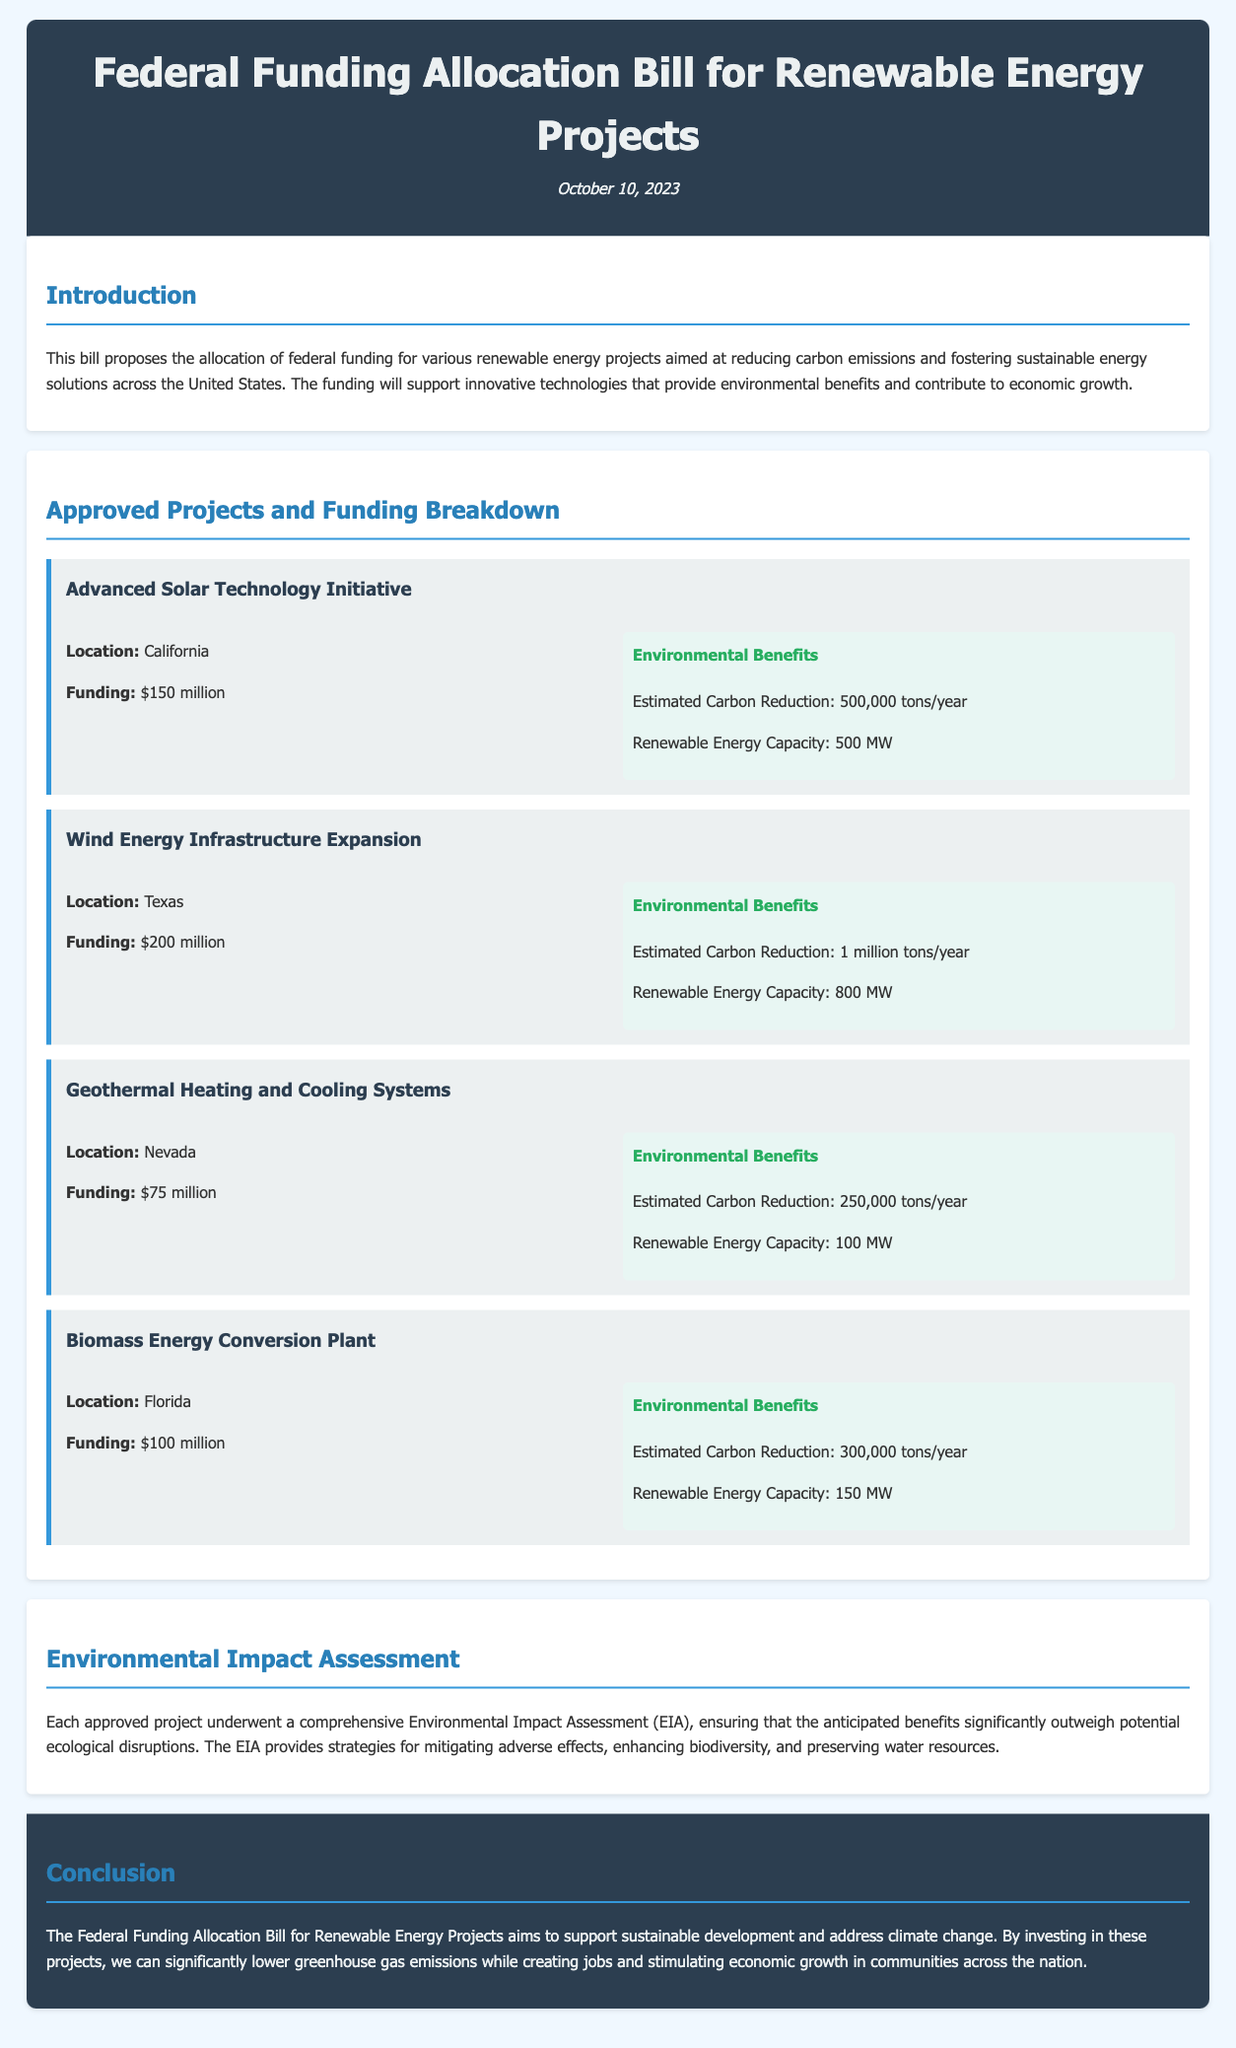what is the title of the bill? The title of the bill is stated at the top of the document.
Answer: Federal Funding Allocation Bill for Renewable Energy Projects when was the bill published? The publication date is mentioned beneath the title in the document.
Answer: October 10, 2023 how much funding is allocated to the Advanced Solar Technology Initiative? The funding amount for the Advanced Solar Technology Initiative is specified in the project section.
Answer: $150 million what is the estimated carbon reduction for the Wind Energy Infrastructure Expansion? The estimated carbon reduction for this project is mentioned in the environmental benefits section.
Answer: 1 million tons/year which state hosts the Biomass Energy Conversion Plant? The location of the Biomass Energy Conversion Plant is specified in the project section.
Answer: Florida how many megawatts of renewable energy capacity does the Geothermal Heating and Cooling Systems project have? The renewable energy capacity for this project is detailed in the project section.
Answer: 100 MW what is the total funding allocated to all approved projects? The total funding is the sum of all individual project funding amounts stated in the bill.
Answer: $525 million which project has the highest renewable energy capacity? The project with the highest capacity is identified in the project details.
Answer: Wind Energy Infrastructure Expansion what is the purpose of the Environmental Impact Assessment mentioned in the document? The purpose of the Environmental Impact Assessment is briefly described in the environmental impact assessment section.
Answer: To ensure anticipated benefits significantly outweigh potential ecological disruptions 